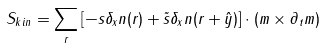<formula> <loc_0><loc_0><loc_500><loc_500>S _ { k i n } = \sum _ { r } \left [ - s \delta _ { x } { n } ( { r } ) + \tilde { s } \delta _ { x } { n } ( { r } + { \hat { y } } ) \right ] \cdot ( { m } \times \partial _ { t } { m } )</formula> 